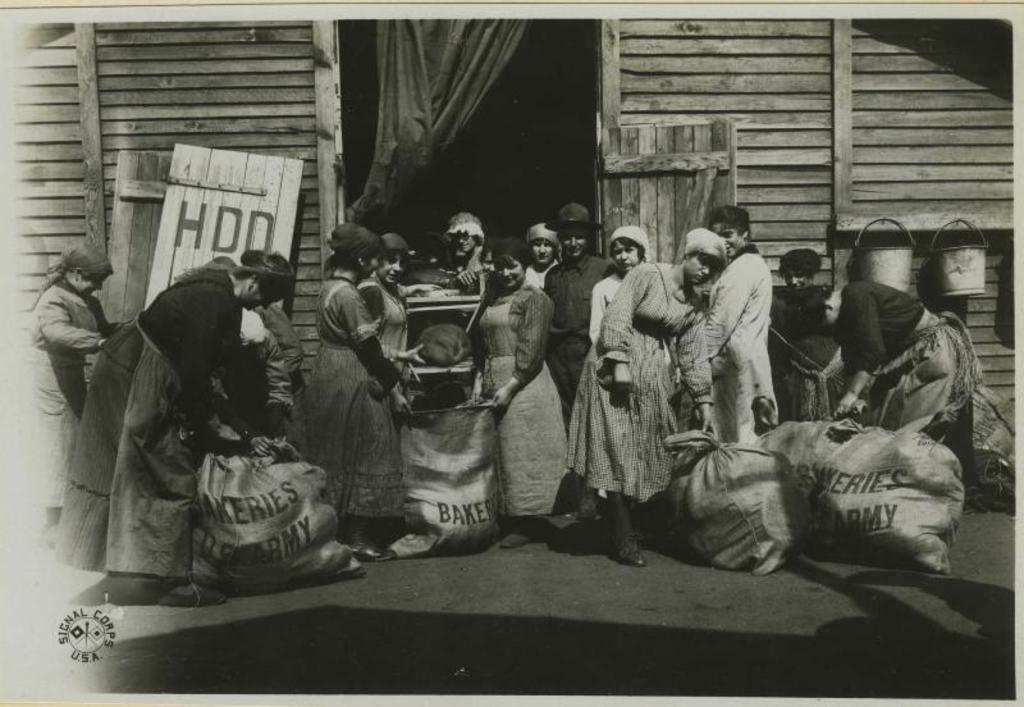What can be seen in the image? There are people standing in the image, and there is a wooden house with a door to enter. Where are the buckets located in the image? The buckets are hanging on the right side of the image. What type of lip can be seen on the door in the image? There is no lip present on the door in the image. What story is being told by the people in the image? The image does not depict a story being told by the people; it simply shows them standing near the wooden house. 